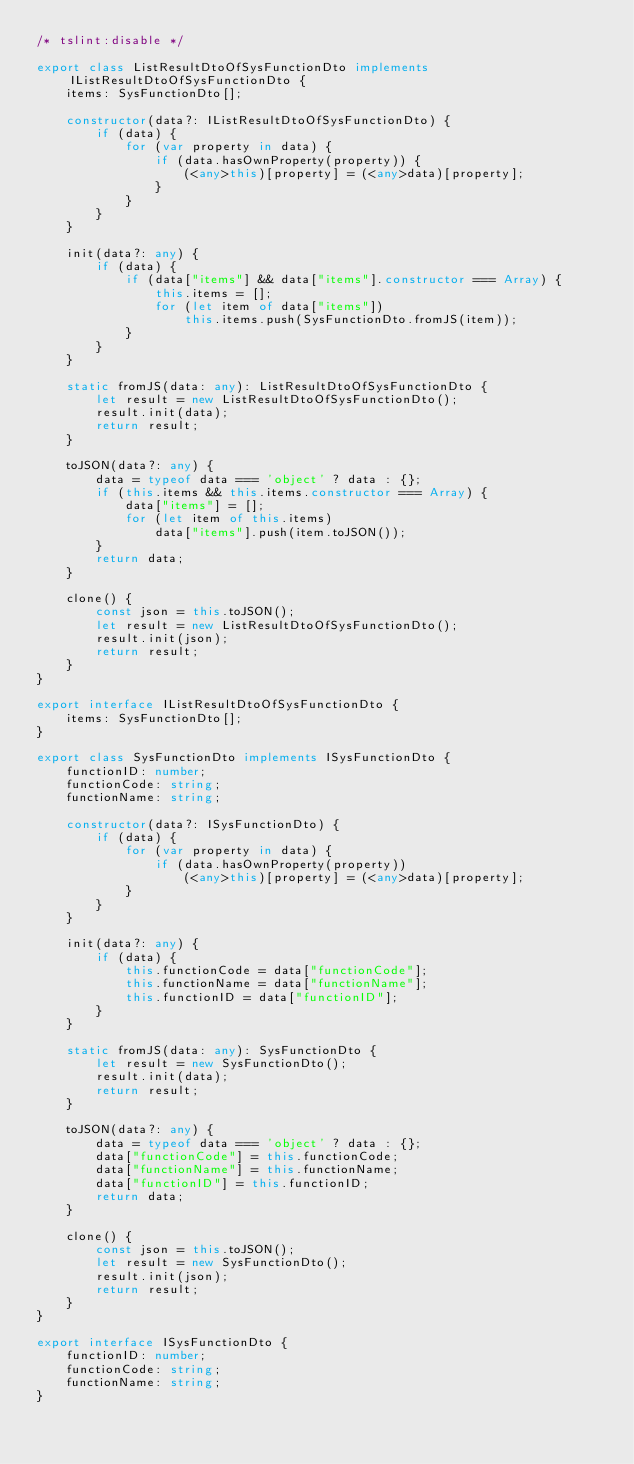<code> <loc_0><loc_0><loc_500><loc_500><_TypeScript_>/* tslint:disable */

export class ListResultDtoOfSysFunctionDto implements IListResultDtoOfSysFunctionDto {
    items: SysFunctionDto[];

    constructor(data?: IListResultDtoOfSysFunctionDto) {
        if (data) {
            for (var property in data) {
                if (data.hasOwnProperty(property)) {
                    (<any>this)[property] = (<any>data)[property];
                }
            }
        }
    }

    init(data?: any) {
        if (data) {
            if (data["items"] && data["items"].constructor === Array) {
                this.items = [];
                for (let item of data["items"])
                    this.items.push(SysFunctionDto.fromJS(item));
            }
        }
    }

    static fromJS(data: any): ListResultDtoOfSysFunctionDto {
        let result = new ListResultDtoOfSysFunctionDto();
        result.init(data);
        return result;
    }

    toJSON(data?: any) {
        data = typeof data === 'object' ? data : {};
        if (this.items && this.items.constructor === Array) {
            data["items"] = [];
            for (let item of this.items)
                data["items"].push(item.toJSON());
        }
        return data; 
    }

    clone() {
        const json = this.toJSON();
        let result = new ListResultDtoOfSysFunctionDto();
        result.init(json);
        return result;
    }
}

export interface IListResultDtoOfSysFunctionDto {
    items: SysFunctionDto[];
}

export class SysFunctionDto implements ISysFunctionDto {
    functionID: number;
    functionCode: string;
    functionName: string;

    constructor(data?: ISysFunctionDto) {
        if (data) {
            for (var property in data) {
                if (data.hasOwnProperty(property))
                    (<any>this)[property] = (<any>data)[property];
            }
        }
    }

    init(data?: any) {
        if (data) {
            this.functionCode = data["functionCode"];
            this.functionName = data["functionName"];
            this.functionID = data["functionID"];
        }
    }

    static fromJS(data: any): SysFunctionDto {
        let result = new SysFunctionDto();
        result.init(data);
        return result;
    }

    toJSON(data?: any) {
        data = typeof data === 'object' ? data : {};
        data["functionCode"] = this.functionCode;
        data["functionName"] = this.functionName;
        data["functionID"] = this.functionID;
        return data; 
    }

    clone() {
        const json = this.toJSON();
        let result = new SysFunctionDto();
        result.init(json);
        return result;
    }
}

export interface ISysFunctionDto {
    functionID: number;
    functionCode: string;
    functionName: string;
}</code> 